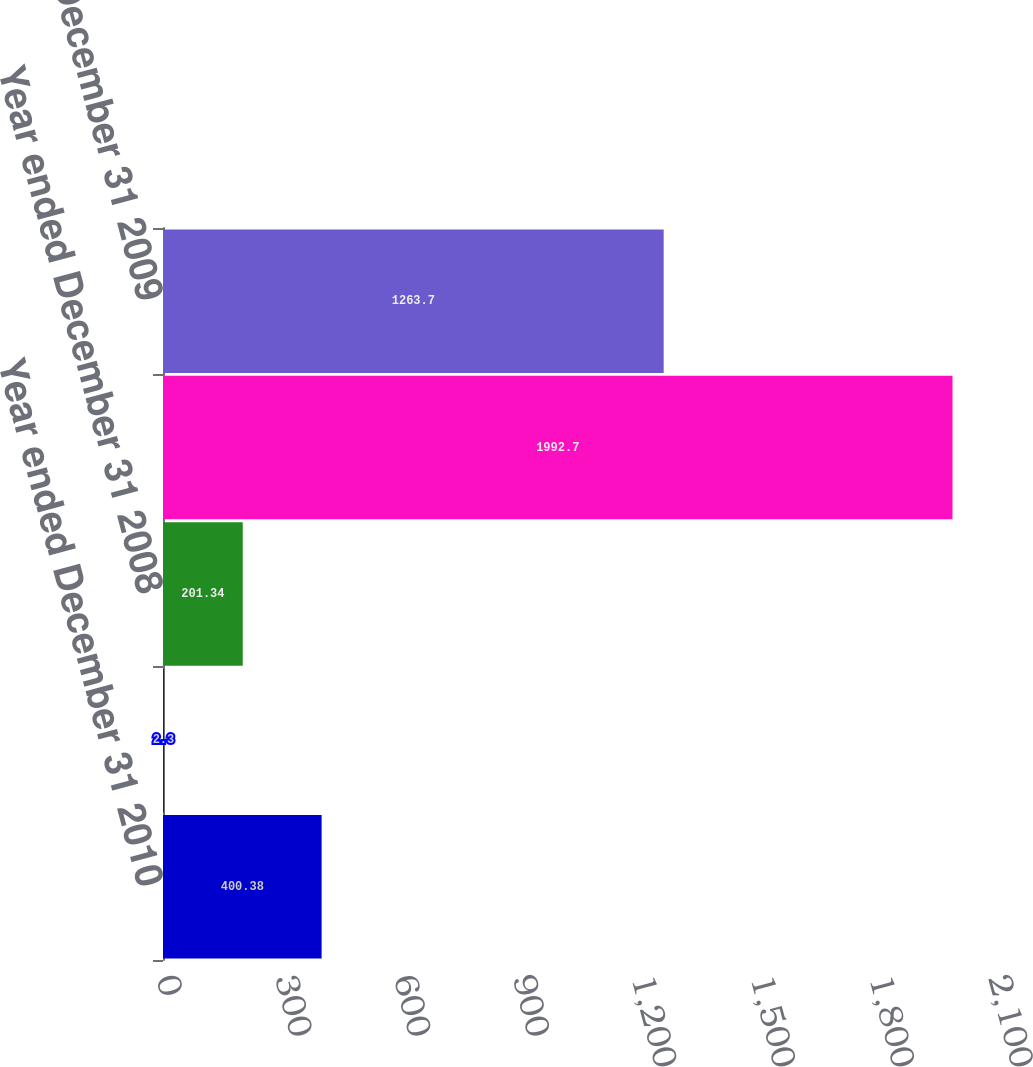Convert chart to OTSL. <chart><loc_0><loc_0><loc_500><loc_500><bar_chart><fcel>Year ended December 31 2010<fcel>Year ended December 31 2009<fcel>Year ended December 31 2008<fcel>December 31 2010<fcel>December 31 2009<nl><fcel>400.38<fcel>2.3<fcel>201.34<fcel>1992.7<fcel>1263.7<nl></chart> 